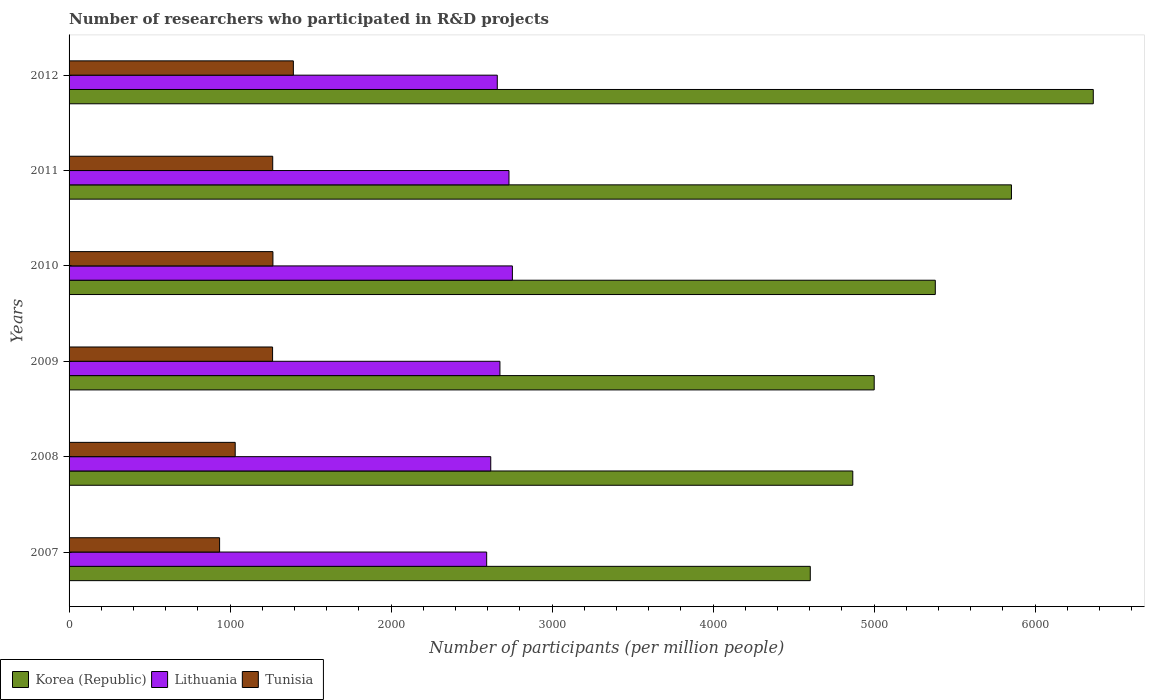Are the number of bars per tick equal to the number of legend labels?
Provide a succinct answer. Yes. How many bars are there on the 2nd tick from the top?
Give a very brief answer. 3. How many bars are there on the 5th tick from the bottom?
Keep it short and to the point. 3. What is the label of the 6th group of bars from the top?
Your response must be concise. 2007. In how many cases, is the number of bars for a given year not equal to the number of legend labels?
Keep it short and to the point. 0. What is the number of researchers who participated in R&D projects in Tunisia in 2007?
Provide a succinct answer. 934.97. Across all years, what is the maximum number of researchers who participated in R&D projects in Lithuania?
Provide a short and direct response. 2753.59. Across all years, what is the minimum number of researchers who participated in R&D projects in Korea (Republic)?
Keep it short and to the point. 4603.84. In which year was the number of researchers who participated in R&D projects in Korea (Republic) minimum?
Your answer should be very brief. 2007. What is the total number of researchers who participated in R&D projects in Korea (Republic) in the graph?
Keep it short and to the point. 3.21e+04. What is the difference between the number of researchers who participated in R&D projects in Lithuania in 2008 and that in 2012?
Your response must be concise. -40.6. What is the difference between the number of researchers who participated in R&D projects in Korea (Republic) in 2007 and the number of researchers who participated in R&D projects in Lithuania in 2012?
Offer a terse response. 1944.13. What is the average number of researchers who participated in R&D projects in Korea (Republic) per year?
Provide a short and direct response. 5344.62. In the year 2009, what is the difference between the number of researchers who participated in R&D projects in Lithuania and number of researchers who participated in R&D projects in Tunisia?
Offer a very short reply. 1412.18. In how many years, is the number of researchers who participated in R&D projects in Lithuania greater than 6000 ?
Offer a very short reply. 0. What is the ratio of the number of researchers who participated in R&D projects in Korea (Republic) in 2007 to that in 2012?
Your response must be concise. 0.72. Is the number of researchers who participated in R&D projects in Korea (Republic) in 2007 less than that in 2010?
Provide a short and direct response. Yes. Is the difference between the number of researchers who participated in R&D projects in Lithuania in 2008 and 2010 greater than the difference between the number of researchers who participated in R&D projects in Tunisia in 2008 and 2010?
Make the answer very short. Yes. What is the difference between the highest and the second highest number of researchers who participated in R&D projects in Lithuania?
Your response must be concise. 21.22. What is the difference between the highest and the lowest number of researchers who participated in R&D projects in Lithuania?
Offer a terse response. 159.77. In how many years, is the number of researchers who participated in R&D projects in Korea (Republic) greater than the average number of researchers who participated in R&D projects in Korea (Republic) taken over all years?
Provide a succinct answer. 3. What does the 2nd bar from the top in 2009 represents?
Make the answer very short. Lithuania. What does the 2nd bar from the bottom in 2012 represents?
Your answer should be very brief. Lithuania. Is it the case that in every year, the sum of the number of researchers who participated in R&D projects in Lithuania and number of researchers who participated in R&D projects in Tunisia is greater than the number of researchers who participated in R&D projects in Korea (Republic)?
Offer a terse response. No. How many years are there in the graph?
Provide a succinct answer. 6. Are the values on the major ticks of X-axis written in scientific E-notation?
Give a very brief answer. No. Does the graph contain any zero values?
Your response must be concise. No. Does the graph contain grids?
Offer a very short reply. No. What is the title of the graph?
Make the answer very short. Number of researchers who participated in R&D projects. What is the label or title of the X-axis?
Your response must be concise. Number of participants (per million people). What is the label or title of the Y-axis?
Make the answer very short. Years. What is the Number of participants (per million people) of Korea (Republic) in 2007?
Offer a very short reply. 4603.84. What is the Number of participants (per million people) in Lithuania in 2007?
Offer a terse response. 2593.81. What is the Number of participants (per million people) in Tunisia in 2007?
Offer a very short reply. 934.97. What is the Number of participants (per million people) in Korea (Republic) in 2008?
Provide a short and direct response. 4867.81. What is the Number of participants (per million people) of Lithuania in 2008?
Ensure brevity in your answer.  2619.11. What is the Number of participants (per million people) of Tunisia in 2008?
Your answer should be very brief. 1031.89. What is the Number of participants (per million people) of Korea (Republic) in 2009?
Keep it short and to the point. 5000.85. What is the Number of participants (per million people) of Lithuania in 2009?
Your response must be concise. 2676.18. What is the Number of participants (per million people) of Tunisia in 2009?
Offer a very short reply. 1263.99. What is the Number of participants (per million people) of Korea (Republic) in 2010?
Your answer should be compact. 5380.28. What is the Number of participants (per million people) in Lithuania in 2010?
Ensure brevity in your answer.  2753.59. What is the Number of participants (per million people) of Tunisia in 2010?
Offer a terse response. 1266.17. What is the Number of participants (per million people) in Korea (Republic) in 2011?
Keep it short and to the point. 5853.33. What is the Number of participants (per million people) in Lithuania in 2011?
Offer a very short reply. 2732.37. What is the Number of participants (per million people) in Tunisia in 2011?
Your answer should be compact. 1264.91. What is the Number of participants (per million people) of Korea (Republic) in 2012?
Provide a succinct answer. 6361.6. What is the Number of participants (per million people) of Lithuania in 2012?
Give a very brief answer. 2659.71. What is the Number of participants (per million people) in Tunisia in 2012?
Offer a terse response. 1393.1. Across all years, what is the maximum Number of participants (per million people) of Korea (Republic)?
Give a very brief answer. 6361.6. Across all years, what is the maximum Number of participants (per million people) of Lithuania?
Your answer should be compact. 2753.59. Across all years, what is the maximum Number of participants (per million people) of Tunisia?
Offer a very short reply. 1393.1. Across all years, what is the minimum Number of participants (per million people) of Korea (Republic)?
Your response must be concise. 4603.84. Across all years, what is the minimum Number of participants (per million people) in Lithuania?
Your answer should be compact. 2593.81. Across all years, what is the minimum Number of participants (per million people) in Tunisia?
Keep it short and to the point. 934.97. What is the total Number of participants (per million people) in Korea (Republic) in the graph?
Your answer should be very brief. 3.21e+04. What is the total Number of participants (per million people) of Lithuania in the graph?
Make the answer very short. 1.60e+04. What is the total Number of participants (per million people) in Tunisia in the graph?
Offer a terse response. 7155.03. What is the difference between the Number of participants (per million people) in Korea (Republic) in 2007 and that in 2008?
Your answer should be very brief. -263.98. What is the difference between the Number of participants (per million people) in Lithuania in 2007 and that in 2008?
Make the answer very short. -25.29. What is the difference between the Number of participants (per million people) of Tunisia in 2007 and that in 2008?
Make the answer very short. -96.92. What is the difference between the Number of participants (per million people) in Korea (Republic) in 2007 and that in 2009?
Offer a terse response. -397.02. What is the difference between the Number of participants (per million people) in Lithuania in 2007 and that in 2009?
Give a very brief answer. -82.36. What is the difference between the Number of participants (per million people) in Tunisia in 2007 and that in 2009?
Offer a very short reply. -329.02. What is the difference between the Number of participants (per million people) in Korea (Republic) in 2007 and that in 2010?
Make the answer very short. -776.44. What is the difference between the Number of participants (per million people) in Lithuania in 2007 and that in 2010?
Offer a terse response. -159.77. What is the difference between the Number of participants (per million people) in Tunisia in 2007 and that in 2010?
Your response must be concise. -331.2. What is the difference between the Number of participants (per million people) in Korea (Republic) in 2007 and that in 2011?
Give a very brief answer. -1249.49. What is the difference between the Number of participants (per million people) of Lithuania in 2007 and that in 2011?
Provide a short and direct response. -138.56. What is the difference between the Number of participants (per million people) of Tunisia in 2007 and that in 2011?
Keep it short and to the point. -329.94. What is the difference between the Number of participants (per million people) of Korea (Republic) in 2007 and that in 2012?
Offer a terse response. -1757.76. What is the difference between the Number of participants (per million people) of Lithuania in 2007 and that in 2012?
Keep it short and to the point. -65.89. What is the difference between the Number of participants (per million people) of Tunisia in 2007 and that in 2012?
Ensure brevity in your answer.  -458.13. What is the difference between the Number of participants (per million people) in Korea (Republic) in 2008 and that in 2009?
Ensure brevity in your answer.  -133.04. What is the difference between the Number of participants (per million people) of Lithuania in 2008 and that in 2009?
Keep it short and to the point. -57.07. What is the difference between the Number of participants (per million people) of Tunisia in 2008 and that in 2009?
Your answer should be compact. -232.1. What is the difference between the Number of participants (per million people) of Korea (Republic) in 2008 and that in 2010?
Ensure brevity in your answer.  -512.46. What is the difference between the Number of participants (per million people) of Lithuania in 2008 and that in 2010?
Keep it short and to the point. -134.48. What is the difference between the Number of participants (per million people) in Tunisia in 2008 and that in 2010?
Keep it short and to the point. -234.28. What is the difference between the Number of participants (per million people) in Korea (Republic) in 2008 and that in 2011?
Offer a terse response. -985.52. What is the difference between the Number of participants (per million people) in Lithuania in 2008 and that in 2011?
Provide a short and direct response. -113.27. What is the difference between the Number of participants (per million people) in Tunisia in 2008 and that in 2011?
Keep it short and to the point. -233.02. What is the difference between the Number of participants (per million people) in Korea (Republic) in 2008 and that in 2012?
Your answer should be compact. -1493.79. What is the difference between the Number of participants (per million people) in Lithuania in 2008 and that in 2012?
Your answer should be compact. -40.6. What is the difference between the Number of participants (per million people) of Tunisia in 2008 and that in 2012?
Make the answer very short. -361.22. What is the difference between the Number of participants (per million people) in Korea (Republic) in 2009 and that in 2010?
Make the answer very short. -379.42. What is the difference between the Number of participants (per million people) of Lithuania in 2009 and that in 2010?
Keep it short and to the point. -77.41. What is the difference between the Number of participants (per million people) in Tunisia in 2009 and that in 2010?
Provide a short and direct response. -2.17. What is the difference between the Number of participants (per million people) of Korea (Republic) in 2009 and that in 2011?
Provide a short and direct response. -852.48. What is the difference between the Number of participants (per million people) of Lithuania in 2009 and that in 2011?
Your answer should be compact. -56.19. What is the difference between the Number of participants (per million people) of Tunisia in 2009 and that in 2011?
Keep it short and to the point. -0.92. What is the difference between the Number of participants (per million people) in Korea (Republic) in 2009 and that in 2012?
Offer a very short reply. -1360.75. What is the difference between the Number of participants (per million people) in Lithuania in 2009 and that in 2012?
Offer a terse response. 16.47. What is the difference between the Number of participants (per million people) in Tunisia in 2009 and that in 2012?
Give a very brief answer. -129.11. What is the difference between the Number of participants (per million people) of Korea (Republic) in 2010 and that in 2011?
Offer a very short reply. -473.05. What is the difference between the Number of participants (per million people) in Lithuania in 2010 and that in 2011?
Provide a succinct answer. 21.22. What is the difference between the Number of participants (per million people) of Tunisia in 2010 and that in 2011?
Offer a very short reply. 1.26. What is the difference between the Number of participants (per million people) in Korea (Republic) in 2010 and that in 2012?
Provide a succinct answer. -981.33. What is the difference between the Number of participants (per million people) in Lithuania in 2010 and that in 2012?
Keep it short and to the point. 93.88. What is the difference between the Number of participants (per million people) of Tunisia in 2010 and that in 2012?
Ensure brevity in your answer.  -126.94. What is the difference between the Number of participants (per million people) of Korea (Republic) in 2011 and that in 2012?
Offer a terse response. -508.27. What is the difference between the Number of participants (per million people) of Lithuania in 2011 and that in 2012?
Your response must be concise. 72.66. What is the difference between the Number of participants (per million people) of Tunisia in 2011 and that in 2012?
Provide a short and direct response. -128.19. What is the difference between the Number of participants (per million people) of Korea (Republic) in 2007 and the Number of participants (per million people) of Lithuania in 2008?
Your answer should be compact. 1984.73. What is the difference between the Number of participants (per million people) of Korea (Republic) in 2007 and the Number of participants (per million people) of Tunisia in 2008?
Keep it short and to the point. 3571.95. What is the difference between the Number of participants (per million people) of Lithuania in 2007 and the Number of participants (per million people) of Tunisia in 2008?
Offer a very short reply. 1561.93. What is the difference between the Number of participants (per million people) of Korea (Republic) in 2007 and the Number of participants (per million people) of Lithuania in 2009?
Provide a succinct answer. 1927.66. What is the difference between the Number of participants (per million people) of Korea (Republic) in 2007 and the Number of participants (per million people) of Tunisia in 2009?
Give a very brief answer. 3339.84. What is the difference between the Number of participants (per million people) in Lithuania in 2007 and the Number of participants (per million people) in Tunisia in 2009?
Ensure brevity in your answer.  1329.82. What is the difference between the Number of participants (per million people) of Korea (Republic) in 2007 and the Number of participants (per million people) of Lithuania in 2010?
Keep it short and to the point. 1850.25. What is the difference between the Number of participants (per million people) in Korea (Republic) in 2007 and the Number of participants (per million people) in Tunisia in 2010?
Keep it short and to the point. 3337.67. What is the difference between the Number of participants (per million people) in Lithuania in 2007 and the Number of participants (per million people) in Tunisia in 2010?
Offer a very short reply. 1327.65. What is the difference between the Number of participants (per million people) of Korea (Republic) in 2007 and the Number of participants (per million people) of Lithuania in 2011?
Keep it short and to the point. 1871.47. What is the difference between the Number of participants (per million people) in Korea (Republic) in 2007 and the Number of participants (per million people) in Tunisia in 2011?
Your answer should be compact. 3338.93. What is the difference between the Number of participants (per million people) in Lithuania in 2007 and the Number of participants (per million people) in Tunisia in 2011?
Your answer should be compact. 1328.9. What is the difference between the Number of participants (per million people) in Korea (Republic) in 2007 and the Number of participants (per million people) in Lithuania in 2012?
Provide a short and direct response. 1944.13. What is the difference between the Number of participants (per million people) in Korea (Republic) in 2007 and the Number of participants (per million people) in Tunisia in 2012?
Give a very brief answer. 3210.73. What is the difference between the Number of participants (per million people) of Lithuania in 2007 and the Number of participants (per million people) of Tunisia in 2012?
Your answer should be compact. 1200.71. What is the difference between the Number of participants (per million people) of Korea (Republic) in 2008 and the Number of participants (per million people) of Lithuania in 2009?
Your response must be concise. 2191.64. What is the difference between the Number of participants (per million people) in Korea (Republic) in 2008 and the Number of participants (per million people) in Tunisia in 2009?
Your answer should be very brief. 3603.82. What is the difference between the Number of participants (per million people) of Lithuania in 2008 and the Number of participants (per million people) of Tunisia in 2009?
Your answer should be very brief. 1355.11. What is the difference between the Number of participants (per million people) in Korea (Republic) in 2008 and the Number of participants (per million people) in Lithuania in 2010?
Provide a succinct answer. 2114.23. What is the difference between the Number of participants (per million people) in Korea (Republic) in 2008 and the Number of participants (per million people) in Tunisia in 2010?
Give a very brief answer. 3601.65. What is the difference between the Number of participants (per million people) of Lithuania in 2008 and the Number of participants (per million people) of Tunisia in 2010?
Provide a succinct answer. 1352.94. What is the difference between the Number of participants (per million people) of Korea (Republic) in 2008 and the Number of participants (per million people) of Lithuania in 2011?
Your answer should be very brief. 2135.44. What is the difference between the Number of participants (per million people) of Korea (Republic) in 2008 and the Number of participants (per million people) of Tunisia in 2011?
Provide a short and direct response. 3602.9. What is the difference between the Number of participants (per million people) of Lithuania in 2008 and the Number of participants (per million people) of Tunisia in 2011?
Your response must be concise. 1354.2. What is the difference between the Number of participants (per million people) in Korea (Republic) in 2008 and the Number of participants (per million people) in Lithuania in 2012?
Ensure brevity in your answer.  2208.11. What is the difference between the Number of participants (per million people) in Korea (Republic) in 2008 and the Number of participants (per million people) in Tunisia in 2012?
Make the answer very short. 3474.71. What is the difference between the Number of participants (per million people) of Lithuania in 2008 and the Number of participants (per million people) of Tunisia in 2012?
Your answer should be very brief. 1226. What is the difference between the Number of participants (per million people) in Korea (Republic) in 2009 and the Number of participants (per million people) in Lithuania in 2010?
Your answer should be very brief. 2247.26. What is the difference between the Number of participants (per million people) in Korea (Republic) in 2009 and the Number of participants (per million people) in Tunisia in 2010?
Provide a succinct answer. 3734.68. What is the difference between the Number of participants (per million people) in Lithuania in 2009 and the Number of participants (per million people) in Tunisia in 2010?
Your answer should be very brief. 1410.01. What is the difference between the Number of participants (per million people) of Korea (Republic) in 2009 and the Number of participants (per million people) of Lithuania in 2011?
Your answer should be very brief. 2268.48. What is the difference between the Number of participants (per million people) in Korea (Republic) in 2009 and the Number of participants (per million people) in Tunisia in 2011?
Your response must be concise. 3735.94. What is the difference between the Number of participants (per million people) in Lithuania in 2009 and the Number of participants (per million people) in Tunisia in 2011?
Keep it short and to the point. 1411.27. What is the difference between the Number of participants (per million people) in Korea (Republic) in 2009 and the Number of participants (per million people) in Lithuania in 2012?
Offer a terse response. 2341.14. What is the difference between the Number of participants (per million people) in Korea (Republic) in 2009 and the Number of participants (per million people) in Tunisia in 2012?
Give a very brief answer. 3607.75. What is the difference between the Number of participants (per million people) in Lithuania in 2009 and the Number of participants (per million people) in Tunisia in 2012?
Your response must be concise. 1283.07. What is the difference between the Number of participants (per million people) of Korea (Republic) in 2010 and the Number of participants (per million people) of Lithuania in 2011?
Your answer should be very brief. 2647.9. What is the difference between the Number of participants (per million people) of Korea (Republic) in 2010 and the Number of participants (per million people) of Tunisia in 2011?
Make the answer very short. 4115.37. What is the difference between the Number of participants (per million people) of Lithuania in 2010 and the Number of participants (per million people) of Tunisia in 2011?
Provide a succinct answer. 1488.68. What is the difference between the Number of participants (per million people) of Korea (Republic) in 2010 and the Number of participants (per million people) of Lithuania in 2012?
Provide a succinct answer. 2720.57. What is the difference between the Number of participants (per million people) of Korea (Republic) in 2010 and the Number of participants (per million people) of Tunisia in 2012?
Keep it short and to the point. 3987.17. What is the difference between the Number of participants (per million people) in Lithuania in 2010 and the Number of participants (per million people) in Tunisia in 2012?
Offer a very short reply. 1360.48. What is the difference between the Number of participants (per million people) of Korea (Republic) in 2011 and the Number of participants (per million people) of Lithuania in 2012?
Provide a short and direct response. 3193.62. What is the difference between the Number of participants (per million people) in Korea (Republic) in 2011 and the Number of participants (per million people) in Tunisia in 2012?
Offer a very short reply. 4460.22. What is the difference between the Number of participants (per million people) of Lithuania in 2011 and the Number of participants (per million people) of Tunisia in 2012?
Make the answer very short. 1339.27. What is the average Number of participants (per million people) of Korea (Republic) per year?
Make the answer very short. 5344.62. What is the average Number of participants (per million people) of Lithuania per year?
Make the answer very short. 2672.46. What is the average Number of participants (per million people) in Tunisia per year?
Keep it short and to the point. 1192.51. In the year 2007, what is the difference between the Number of participants (per million people) of Korea (Republic) and Number of participants (per million people) of Lithuania?
Provide a short and direct response. 2010.02. In the year 2007, what is the difference between the Number of participants (per million people) in Korea (Republic) and Number of participants (per million people) in Tunisia?
Your answer should be very brief. 3668.87. In the year 2007, what is the difference between the Number of participants (per million people) of Lithuania and Number of participants (per million people) of Tunisia?
Your answer should be compact. 1658.84. In the year 2008, what is the difference between the Number of participants (per million people) in Korea (Republic) and Number of participants (per million people) in Lithuania?
Make the answer very short. 2248.71. In the year 2008, what is the difference between the Number of participants (per million people) of Korea (Republic) and Number of participants (per million people) of Tunisia?
Offer a terse response. 3835.92. In the year 2008, what is the difference between the Number of participants (per million people) of Lithuania and Number of participants (per million people) of Tunisia?
Your answer should be compact. 1587.22. In the year 2009, what is the difference between the Number of participants (per million people) of Korea (Republic) and Number of participants (per million people) of Lithuania?
Provide a succinct answer. 2324.68. In the year 2009, what is the difference between the Number of participants (per million people) in Korea (Republic) and Number of participants (per million people) in Tunisia?
Keep it short and to the point. 3736.86. In the year 2009, what is the difference between the Number of participants (per million people) in Lithuania and Number of participants (per million people) in Tunisia?
Offer a very short reply. 1412.18. In the year 2010, what is the difference between the Number of participants (per million people) in Korea (Republic) and Number of participants (per million people) in Lithuania?
Give a very brief answer. 2626.69. In the year 2010, what is the difference between the Number of participants (per million people) in Korea (Republic) and Number of participants (per million people) in Tunisia?
Give a very brief answer. 4114.11. In the year 2010, what is the difference between the Number of participants (per million people) of Lithuania and Number of participants (per million people) of Tunisia?
Your answer should be compact. 1487.42. In the year 2011, what is the difference between the Number of participants (per million people) of Korea (Republic) and Number of participants (per million people) of Lithuania?
Provide a short and direct response. 3120.96. In the year 2011, what is the difference between the Number of participants (per million people) in Korea (Republic) and Number of participants (per million people) in Tunisia?
Your response must be concise. 4588.42. In the year 2011, what is the difference between the Number of participants (per million people) in Lithuania and Number of participants (per million people) in Tunisia?
Give a very brief answer. 1467.46. In the year 2012, what is the difference between the Number of participants (per million people) in Korea (Republic) and Number of participants (per million people) in Lithuania?
Keep it short and to the point. 3701.89. In the year 2012, what is the difference between the Number of participants (per million people) in Korea (Republic) and Number of participants (per million people) in Tunisia?
Make the answer very short. 4968.5. In the year 2012, what is the difference between the Number of participants (per million people) of Lithuania and Number of participants (per million people) of Tunisia?
Offer a terse response. 1266.6. What is the ratio of the Number of participants (per million people) of Korea (Republic) in 2007 to that in 2008?
Keep it short and to the point. 0.95. What is the ratio of the Number of participants (per million people) in Lithuania in 2007 to that in 2008?
Offer a terse response. 0.99. What is the ratio of the Number of participants (per million people) in Tunisia in 2007 to that in 2008?
Offer a terse response. 0.91. What is the ratio of the Number of participants (per million people) of Korea (Republic) in 2007 to that in 2009?
Your response must be concise. 0.92. What is the ratio of the Number of participants (per million people) of Lithuania in 2007 to that in 2009?
Give a very brief answer. 0.97. What is the ratio of the Number of participants (per million people) in Tunisia in 2007 to that in 2009?
Your response must be concise. 0.74. What is the ratio of the Number of participants (per million people) in Korea (Republic) in 2007 to that in 2010?
Provide a short and direct response. 0.86. What is the ratio of the Number of participants (per million people) in Lithuania in 2007 to that in 2010?
Your response must be concise. 0.94. What is the ratio of the Number of participants (per million people) of Tunisia in 2007 to that in 2010?
Make the answer very short. 0.74. What is the ratio of the Number of participants (per million people) of Korea (Republic) in 2007 to that in 2011?
Provide a succinct answer. 0.79. What is the ratio of the Number of participants (per million people) in Lithuania in 2007 to that in 2011?
Provide a succinct answer. 0.95. What is the ratio of the Number of participants (per million people) of Tunisia in 2007 to that in 2011?
Give a very brief answer. 0.74. What is the ratio of the Number of participants (per million people) in Korea (Republic) in 2007 to that in 2012?
Keep it short and to the point. 0.72. What is the ratio of the Number of participants (per million people) of Lithuania in 2007 to that in 2012?
Your response must be concise. 0.98. What is the ratio of the Number of participants (per million people) of Tunisia in 2007 to that in 2012?
Offer a terse response. 0.67. What is the ratio of the Number of participants (per million people) in Korea (Republic) in 2008 to that in 2009?
Offer a terse response. 0.97. What is the ratio of the Number of participants (per million people) in Lithuania in 2008 to that in 2009?
Your answer should be very brief. 0.98. What is the ratio of the Number of participants (per million people) in Tunisia in 2008 to that in 2009?
Keep it short and to the point. 0.82. What is the ratio of the Number of participants (per million people) in Korea (Republic) in 2008 to that in 2010?
Keep it short and to the point. 0.9. What is the ratio of the Number of participants (per million people) in Lithuania in 2008 to that in 2010?
Ensure brevity in your answer.  0.95. What is the ratio of the Number of participants (per million people) of Tunisia in 2008 to that in 2010?
Your response must be concise. 0.81. What is the ratio of the Number of participants (per million people) of Korea (Republic) in 2008 to that in 2011?
Provide a short and direct response. 0.83. What is the ratio of the Number of participants (per million people) of Lithuania in 2008 to that in 2011?
Make the answer very short. 0.96. What is the ratio of the Number of participants (per million people) of Tunisia in 2008 to that in 2011?
Provide a succinct answer. 0.82. What is the ratio of the Number of participants (per million people) in Korea (Republic) in 2008 to that in 2012?
Keep it short and to the point. 0.77. What is the ratio of the Number of participants (per million people) in Lithuania in 2008 to that in 2012?
Ensure brevity in your answer.  0.98. What is the ratio of the Number of participants (per million people) of Tunisia in 2008 to that in 2012?
Give a very brief answer. 0.74. What is the ratio of the Number of participants (per million people) in Korea (Republic) in 2009 to that in 2010?
Your answer should be very brief. 0.93. What is the ratio of the Number of participants (per million people) in Lithuania in 2009 to that in 2010?
Give a very brief answer. 0.97. What is the ratio of the Number of participants (per million people) of Korea (Republic) in 2009 to that in 2011?
Your answer should be very brief. 0.85. What is the ratio of the Number of participants (per million people) of Lithuania in 2009 to that in 2011?
Your answer should be compact. 0.98. What is the ratio of the Number of participants (per million people) in Korea (Republic) in 2009 to that in 2012?
Give a very brief answer. 0.79. What is the ratio of the Number of participants (per million people) of Lithuania in 2009 to that in 2012?
Your answer should be very brief. 1.01. What is the ratio of the Number of participants (per million people) of Tunisia in 2009 to that in 2012?
Ensure brevity in your answer.  0.91. What is the ratio of the Number of participants (per million people) of Korea (Republic) in 2010 to that in 2011?
Ensure brevity in your answer.  0.92. What is the ratio of the Number of participants (per million people) in Lithuania in 2010 to that in 2011?
Offer a terse response. 1.01. What is the ratio of the Number of participants (per million people) of Tunisia in 2010 to that in 2011?
Provide a short and direct response. 1. What is the ratio of the Number of participants (per million people) in Korea (Republic) in 2010 to that in 2012?
Offer a very short reply. 0.85. What is the ratio of the Number of participants (per million people) of Lithuania in 2010 to that in 2012?
Your response must be concise. 1.04. What is the ratio of the Number of participants (per million people) of Tunisia in 2010 to that in 2012?
Offer a very short reply. 0.91. What is the ratio of the Number of participants (per million people) in Korea (Republic) in 2011 to that in 2012?
Your response must be concise. 0.92. What is the ratio of the Number of participants (per million people) in Lithuania in 2011 to that in 2012?
Your response must be concise. 1.03. What is the ratio of the Number of participants (per million people) of Tunisia in 2011 to that in 2012?
Ensure brevity in your answer.  0.91. What is the difference between the highest and the second highest Number of participants (per million people) in Korea (Republic)?
Your answer should be compact. 508.27. What is the difference between the highest and the second highest Number of participants (per million people) in Lithuania?
Keep it short and to the point. 21.22. What is the difference between the highest and the second highest Number of participants (per million people) in Tunisia?
Offer a terse response. 126.94. What is the difference between the highest and the lowest Number of participants (per million people) in Korea (Republic)?
Offer a terse response. 1757.76. What is the difference between the highest and the lowest Number of participants (per million people) of Lithuania?
Your response must be concise. 159.77. What is the difference between the highest and the lowest Number of participants (per million people) in Tunisia?
Ensure brevity in your answer.  458.13. 